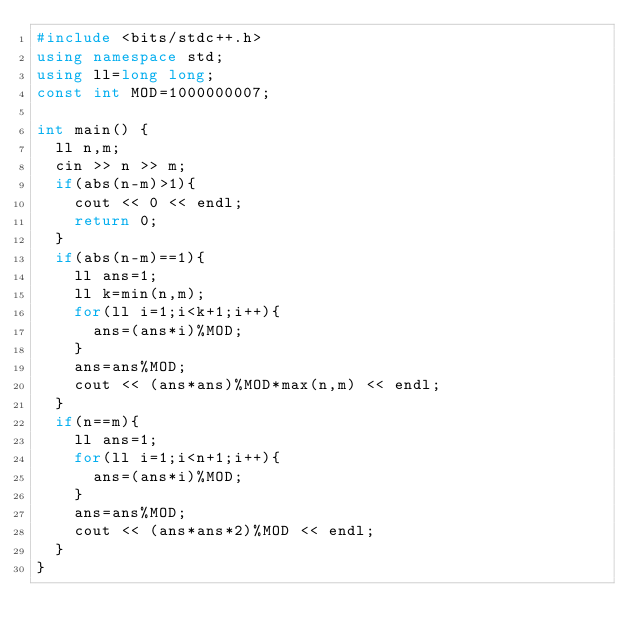<code> <loc_0><loc_0><loc_500><loc_500><_C++_>#include <bits/stdc++.h>
using namespace std;
using ll=long long;
const int MOD=1000000007;

int main() {
  ll n,m;
  cin >> n >> m;
  if(abs(n-m)>1){
    cout << 0 << endl;
    return 0;
  }
  if(abs(n-m)==1){
    ll ans=1;
    ll k=min(n,m);
    for(ll i=1;i<k+1;i++){
      ans=(ans*i)%MOD;
    }
    ans=ans%MOD;
    cout << (ans*ans)%MOD*max(n,m) << endl;
  }
  if(n==m){
    ll ans=1;
    for(ll i=1;i<n+1;i++){
      ans=(ans*i)%MOD;
    }
    ans=ans%MOD;
    cout << (ans*ans*2)%MOD << endl;
  }
}

</code> 